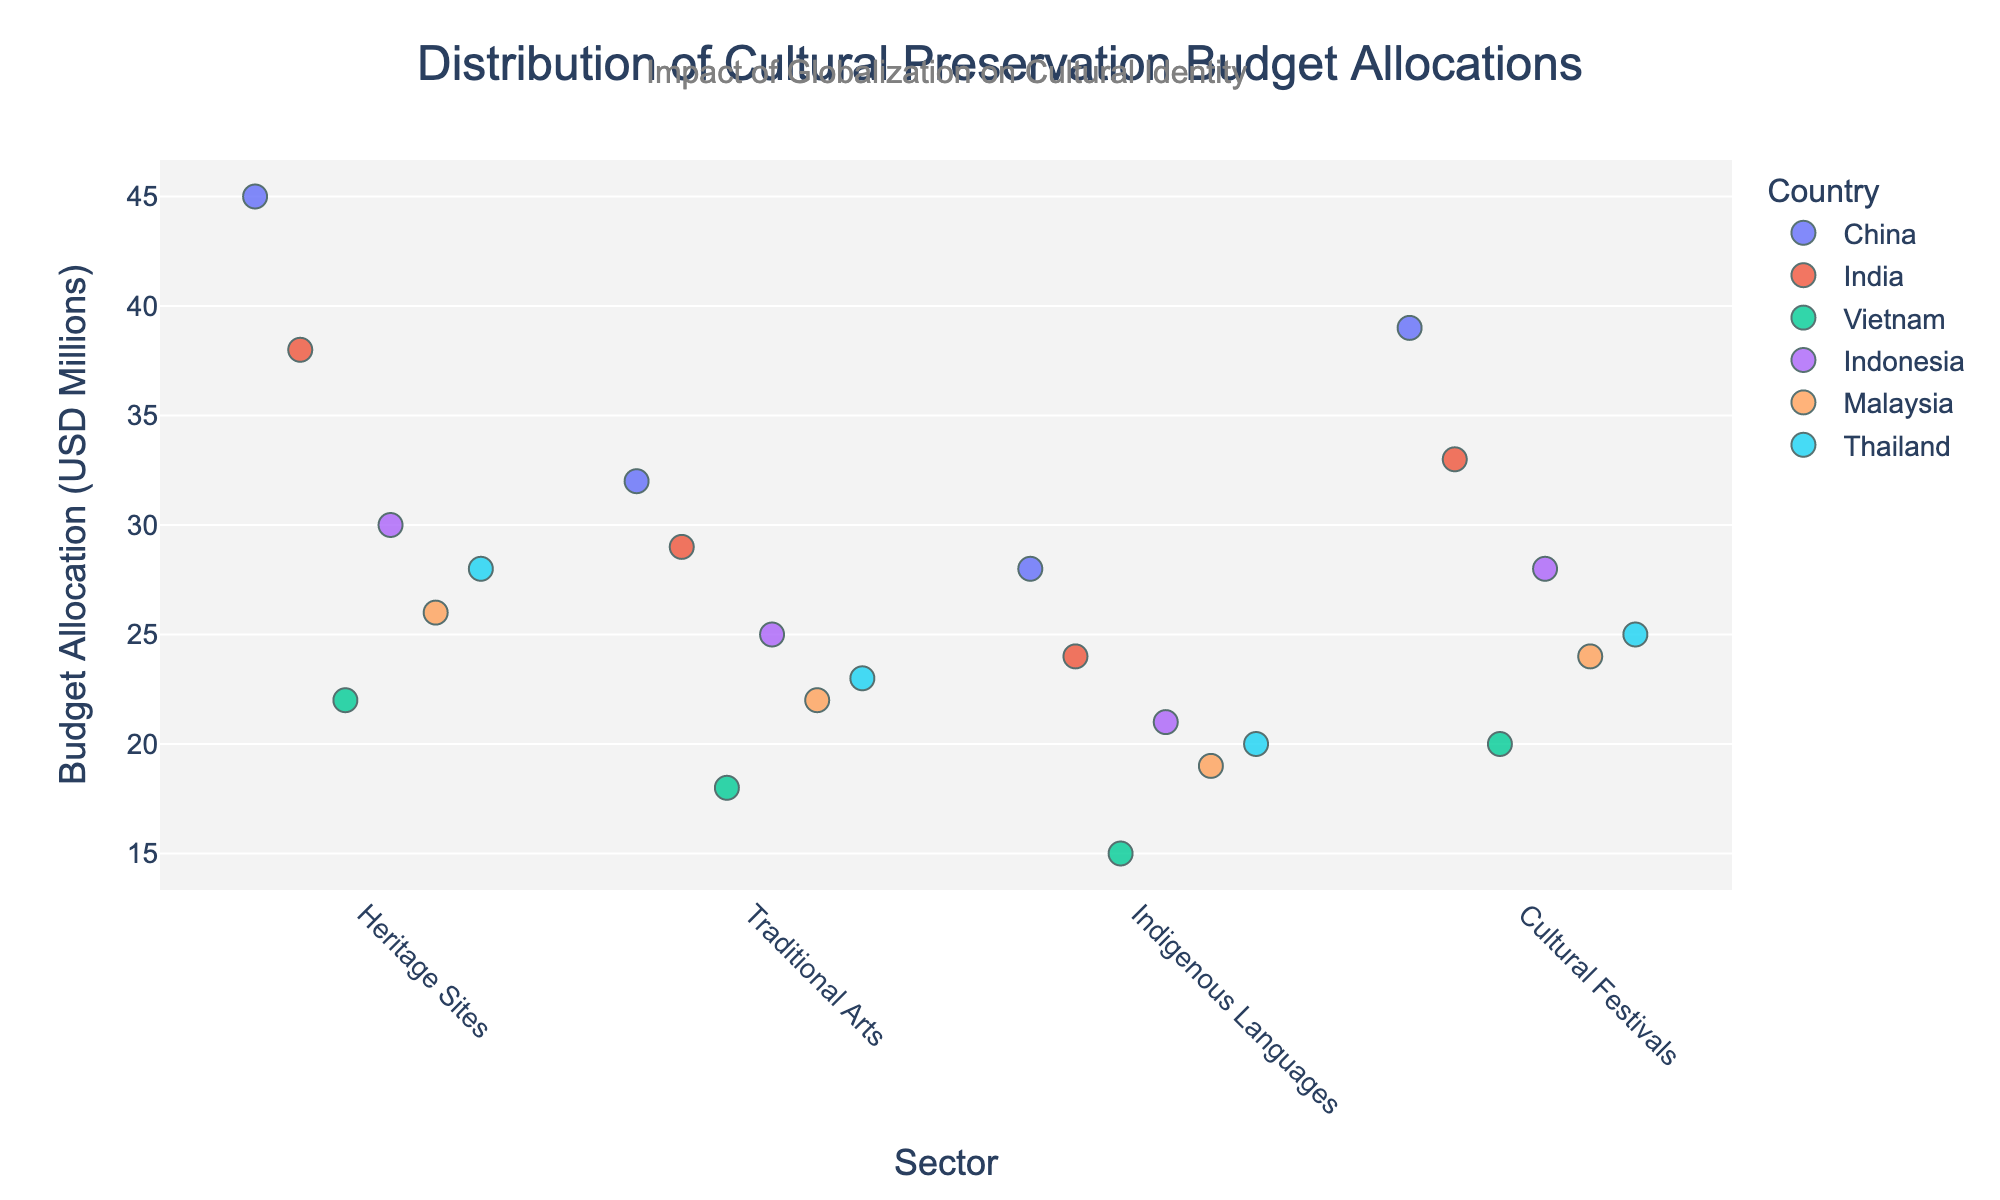What is the total budget allocation for Heritage Sites across all countries? The budget allocations for Heritage Sites are: China (45 million), India (38 million), Vietnam (22 million), Indonesia (30 million), Malaysia (26 million), and Thailand (28 million). Summing them gives 45 + 38 + 22 + 30 + 26 + 28 = 189 million USD.
Answer: 189 million USD Which country has the highest budget allocation for Indigenous Languages? From the plot, comparing the budget allocations for Indigenous Languages: China (28 million), India (24 million), Vietnam (15 million), Indonesia (21 million), Malaysia (19 million), and Thailand (20 million), China has the highest allocation at 28 million USD.
Answer: China How does the budget allocation for Traditional Arts in India compare to that in Thailand? The budget allocation for Traditional Arts in India is 29 million USD, while in Thailand it is 23 million USD. India’s allocation exceeds Thailand’s by 29 - 23 = 6 million USD.
Answer: India has 6 million USD more What is the average budget allocation across all sectors in Vietnam? Adding up the budget allocations for Vietnam's sectors: Heritage Sites (22 million), Traditional Arts (18 million), Indigenous Languages (15 million), and Cultural Festivals (20 million) results in 22 + 18 + 15 + 20 = 75 million USD. Dividing by the number of sectors, 75 / 4 gives the average 18.75 million USD.
Answer: 18.75 million USD Which sector shows the most consistent (least spread out) budget allocations across all countries? Observing the spread of the points in each sector, we see that Indigenous Languages has the least spread, meaning the allocations in this sector are the most consistent across countries.
Answer: Indigenous Languages For which sector does China allocate the most budget? Looking at the budget allocations for China, the values are: Heritage Sites (45 million), Traditional Arts (32 million), Indigenous Languages (28 million), and Cultural Festivals (39 million). Heritage Sites has the highest allocation of 45 million USD.
Answer: Heritage Sites Are there any sectors where all countries allocate less than 30 million USD? Comparing the budget allocations presented: Indigenous Languages has 28 million (China), 24 million (India), 15 million (Vietnam), 21 million (Indonesia), 19 million (Malaysia), and 20 million (Thailand). All these values are below 30 million USD.
Answer: Yes, Indigenous Languages 